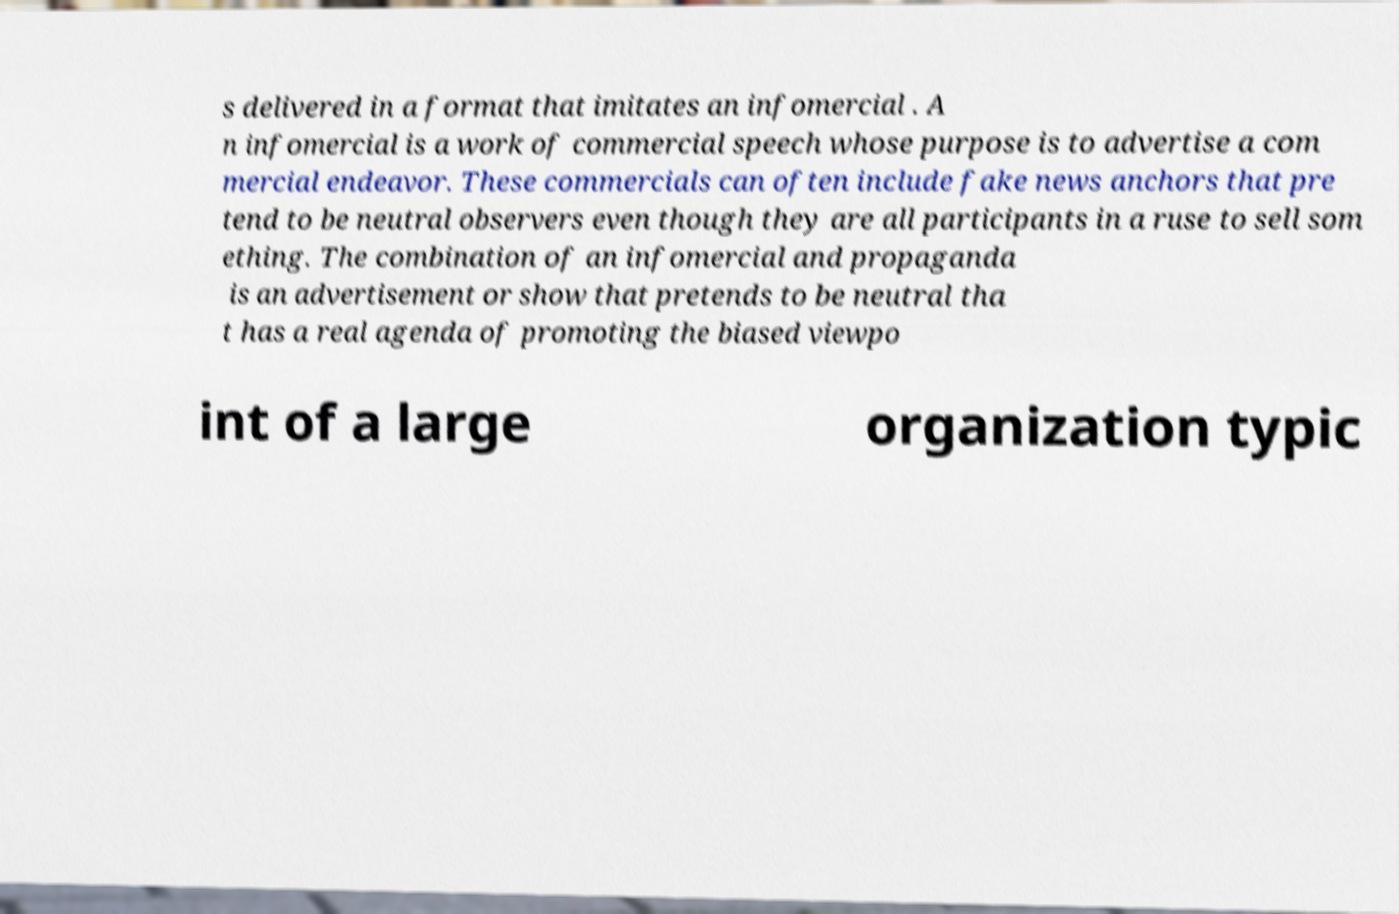Please read and relay the text visible in this image. What does it say? s delivered in a format that imitates an infomercial . A n infomercial is a work of commercial speech whose purpose is to advertise a com mercial endeavor. These commercials can often include fake news anchors that pre tend to be neutral observers even though they are all participants in a ruse to sell som ething. The combination of an infomercial and propaganda is an advertisement or show that pretends to be neutral tha t has a real agenda of promoting the biased viewpo int of a large organization typic 